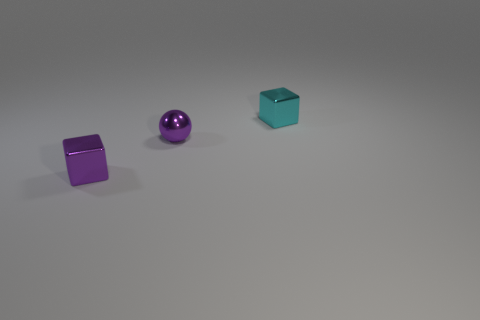What is the shape of the tiny object that is the same color as the ball?
Your answer should be compact. Cube. Is there a small shiny thing of the same color as the tiny metal ball?
Ensure brevity in your answer.  Yes. How many things are tiny cyan shiny cubes or tiny objects that are on the right side of the purple ball?
Keep it short and to the point. 1. Is the number of large yellow things greater than the number of metallic things?
Your answer should be very brief. No. What is the size of the thing that is the same color as the tiny ball?
Your response must be concise. Small. Is there a purple sphere made of the same material as the cyan block?
Your response must be concise. Yes. What number of other objects are there of the same shape as the cyan thing?
Make the answer very short. 1. The cyan cube has what size?
Keep it short and to the point. Small. What number of objects are purple shiny balls or tiny metal cubes?
Provide a succinct answer. 3. How big is the thing that is to the left of the tiny purple sphere?
Offer a very short reply. Small. 